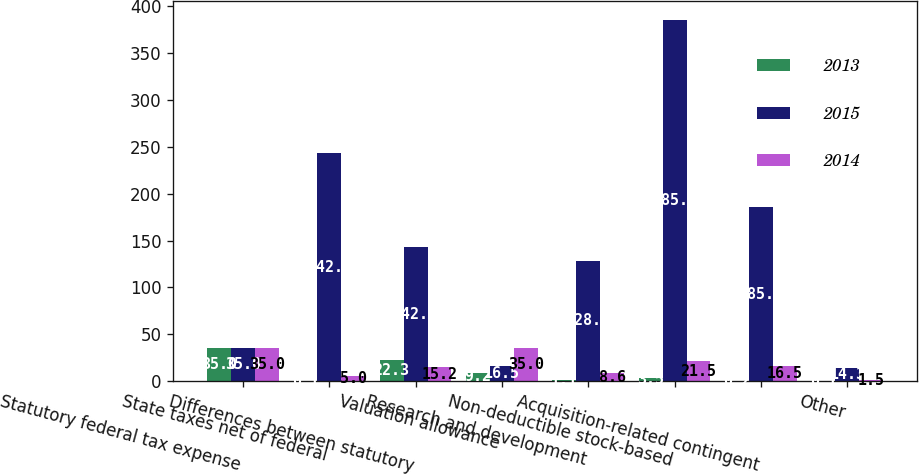Convert chart. <chart><loc_0><loc_0><loc_500><loc_500><stacked_bar_chart><ecel><fcel>Statutory federal tax expense<fcel>State taxes net of federal<fcel>Differences between statutory<fcel>Valuation allowance<fcel>Research and development<fcel>Non-deductible stock-based<fcel>Acquisition-related contingent<fcel>Other<nl><fcel>2013<fcel>35<fcel>0.1<fcel>22.3<fcel>9.2<fcel>1.1<fcel>3.5<fcel>0.2<fcel>0.1<nl><fcel>2015<fcel>35<fcel>242.9<fcel>142.9<fcel>16.5<fcel>128.6<fcel>385.7<fcel>185.7<fcel>14.3<nl><fcel>2014<fcel>35<fcel>5<fcel>15.2<fcel>35<fcel>8.6<fcel>21.5<fcel>16.5<fcel>1.5<nl></chart> 